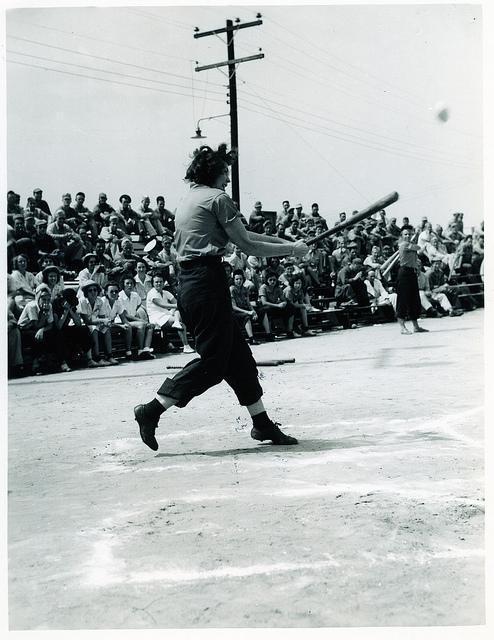What sport are these women most likely playing?
Indicate the correct response and explain using: 'Answer: answer
Rationale: rationale.'
Options: Tennis, softball, lacrosse, croquet. Answer: softball.
Rationale: They have a bat and women usually play this instead of baseball 